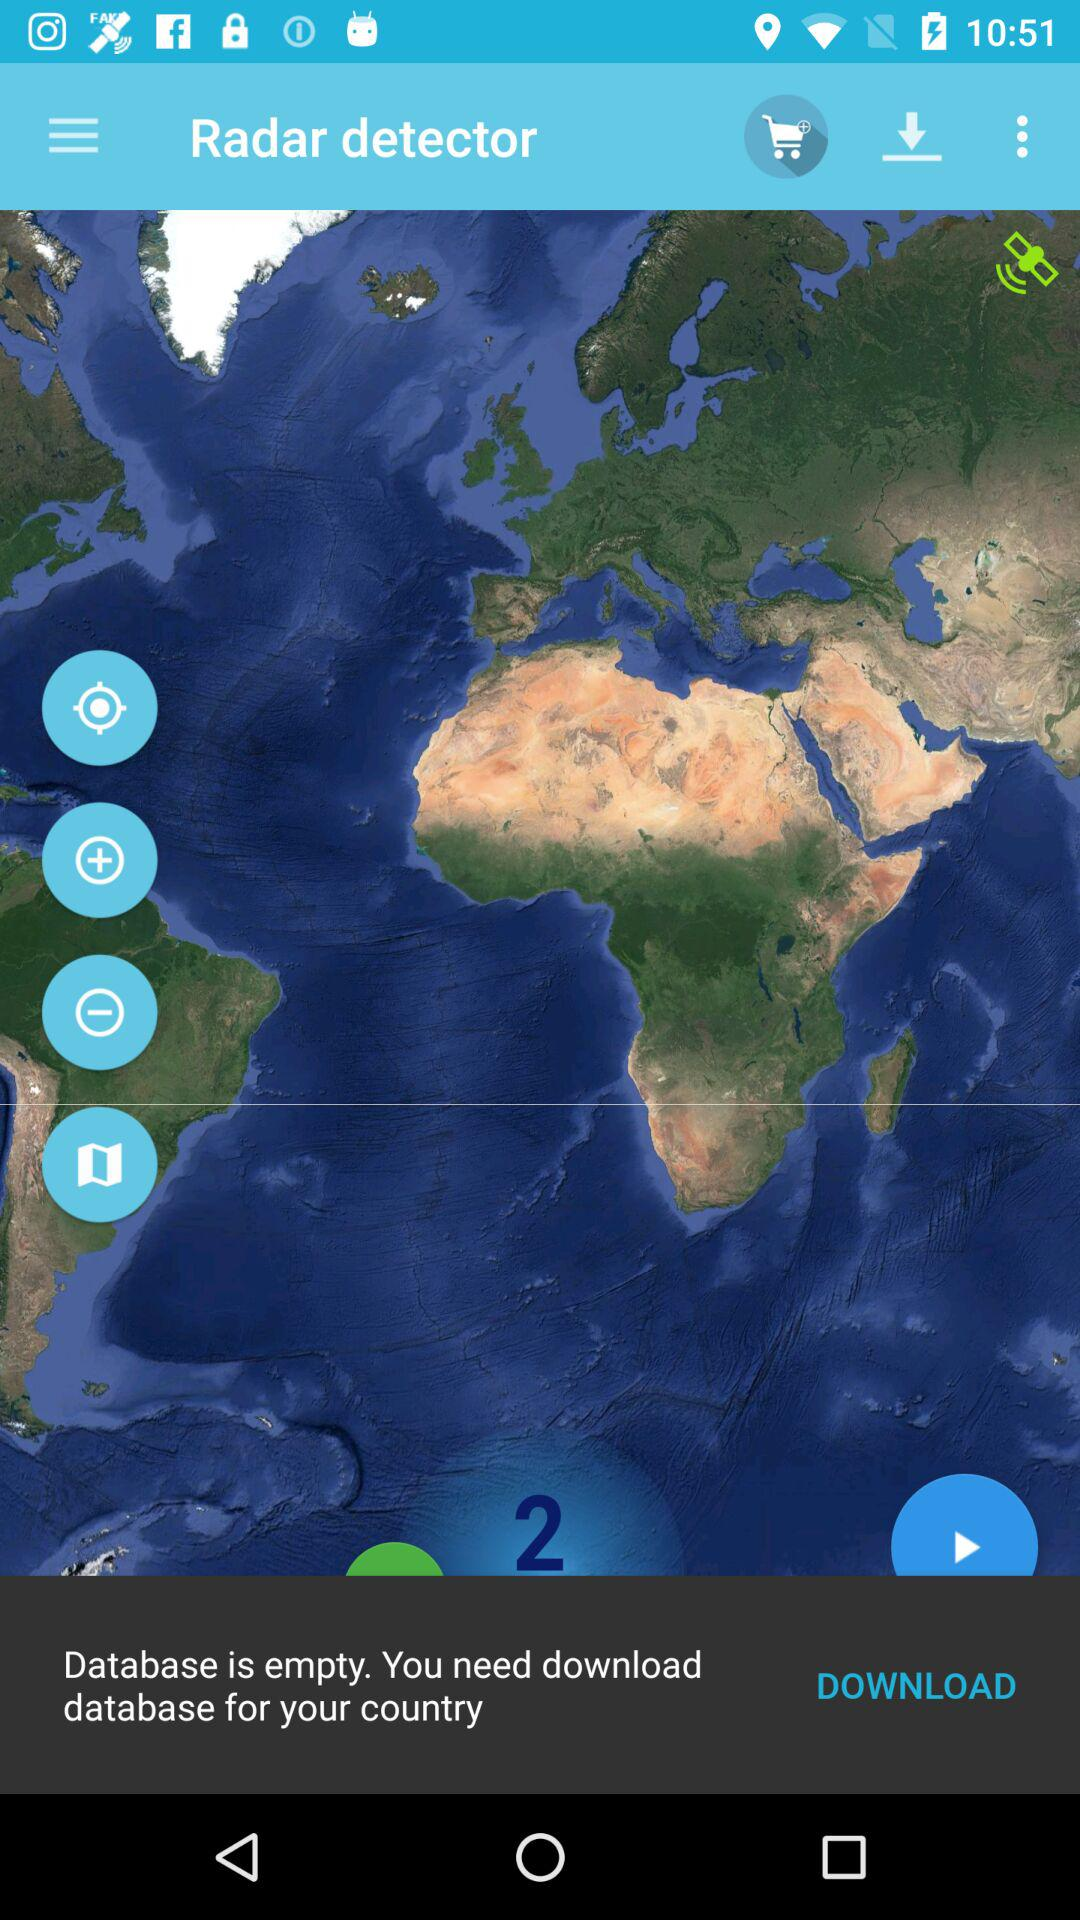What is the app name? The app name is "Radar detector". 